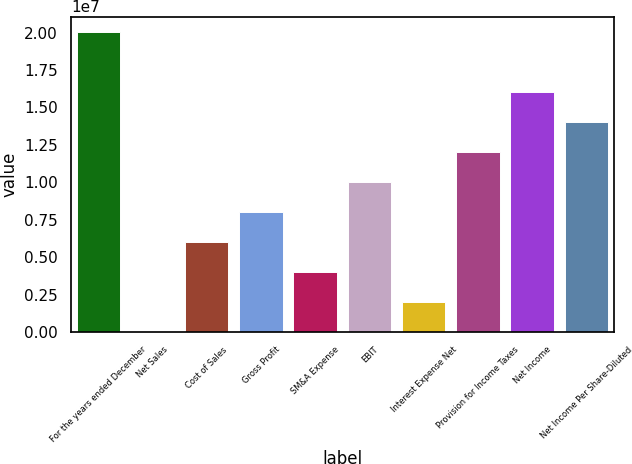Convert chart. <chart><loc_0><loc_0><loc_500><loc_500><bar_chart><fcel>For the years ended December<fcel>Net Sales<fcel>Cost of Sales<fcel>Gross Profit<fcel>SM&A Expense<fcel>EBIT<fcel>Interest Expense Net<fcel>Provision for Income Taxes<fcel>Net Income<fcel>Net Income Per Share-Diluted<nl><fcel>2.0072e+07<fcel>0.1<fcel>6.0216e+06<fcel>8.0288e+06<fcel>4.0144e+06<fcel>1.0036e+07<fcel>2.0072e+06<fcel>1.20432e+07<fcel>1.60576e+07<fcel>1.40504e+07<nl></chart> 